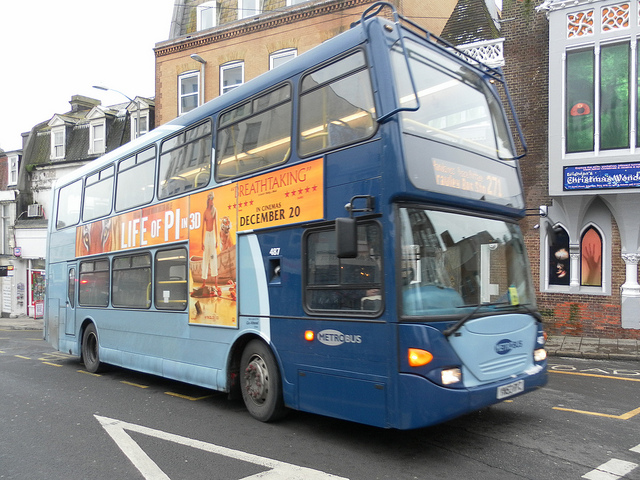<image>What does the blue square symbol on the front of the bus mean? The meaning of the blue square symbol on the front of the bus is unknown. It could be a safety sign, a logo, an advertisement or simply mean nothing. What does the blue square symbol on the front of the bus mean? I don't know what the blue square symbol on the front of the bus means. It could represent safety, advertisement, or something else. 